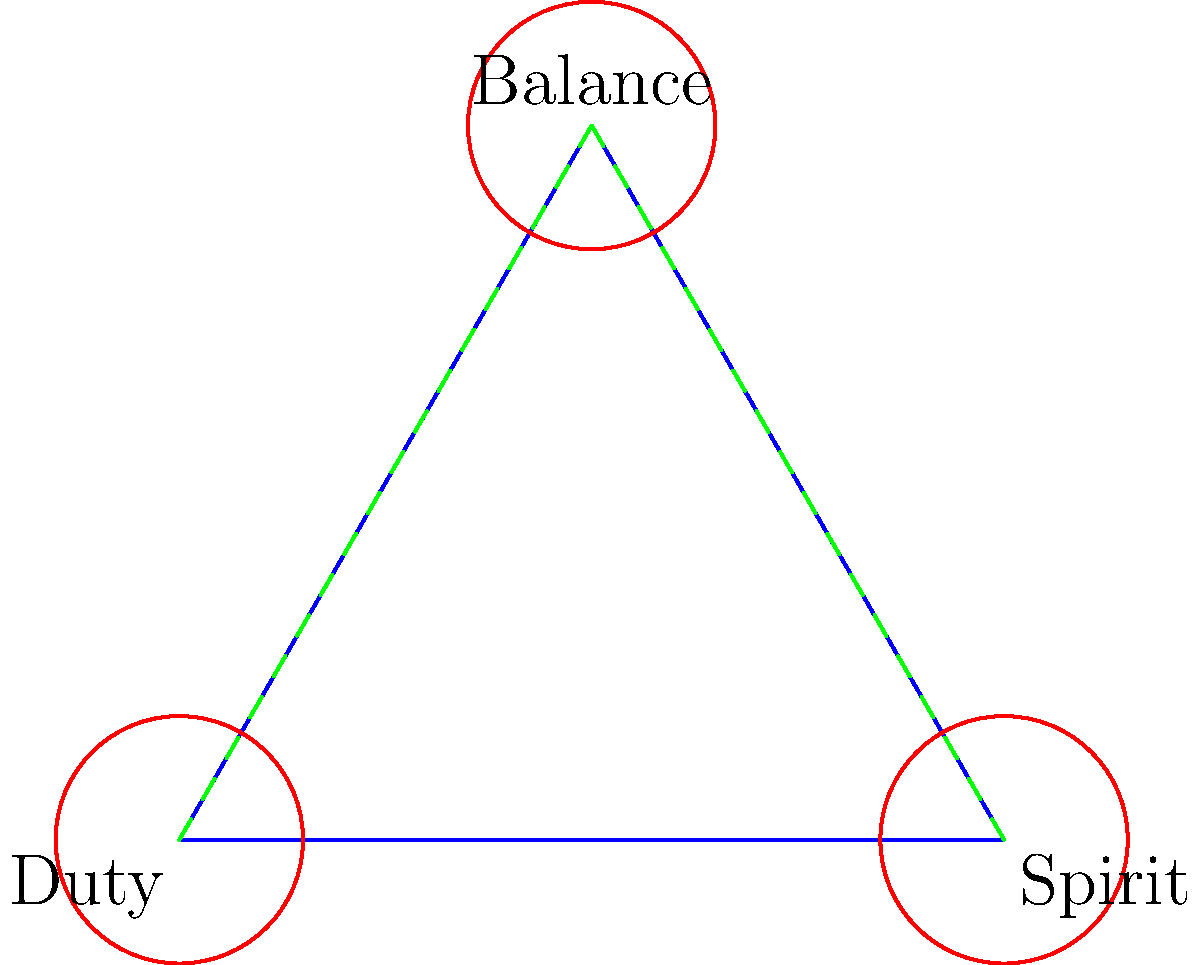Consider the space represented by the triangle above, where each vertex symbolizes an aspect of a navy pilot's life: professional duty, spiritual commitment, and the balance between them. The edges represent the paths connecting these aspects. If we consider this space as a topological space, what is its fundamental group? To determine the fundamental group of this space, we need to follow these steps:

1) First, observe that the space is a 2-dimensional simplex (a filled triangle).

2) The 2-dimensional simplex is homeomorphic to a disk in $\mathbb{R}^2$.

3) The disk in $\mathbb{R}^2$ is simply connected, meaning any loop in this space can be continuously deformed to a single point.

4) The fundamental group of a simply connected space is trivial, consisting only of the identity element.

5) In group theory notation, we denote the trivial group as $\{e\}$ or $0$.

Therefore, the fundamental group of this space is the trivial group.

This result symbolizes that in the context of balancing professional duties and spiritual commitments, all paths (represented by loops in the space) can be reconciled or "deformed" to a single point of view, suggesting the possibility of harmonizing these aspects of life.
Answer: $\{e\}$ or $0$ 